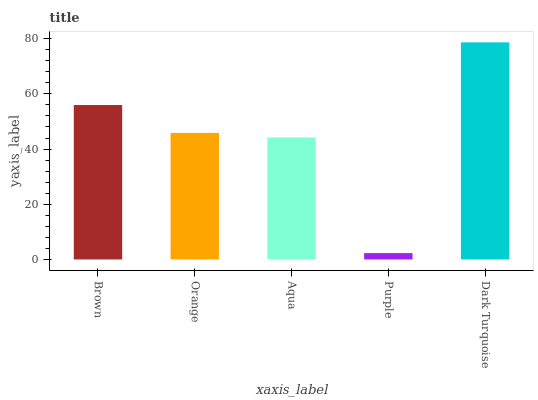Is Purple the minimum?
Answer yes or no. Yes. Is Dark Turquoise the maximum?
Answer yes or no. Yes. Is Orange the minimum?
Answer yes or no. No. Is Orange the maximum?
Answer yes or no. No. Is Brown greater than Orange?
Answer yes or no. Yes. Is Orange less than Brown?
Answer yes or no. Yes. Is Orange greater than Brown?
Answer yes or no. No. Is Brown less than Orange?
Answer yes or no. No. Is Orange the high median?
Answer yes or no. Yes. Is Orange the low median?
Answer yes or no. Yes. Is Brown the high median?
Answer yes or no. No. Is Purple the low median?
Answer yes or no. No. 